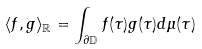Convert formula to latex. <formula><loc_0><loc_0><loc_500><loc_500>\langle f , g \rangle _ { \mathbb { R } } = \int _ { \partial \mathbb { D } } f ( \tau ) g ( \tau ) d \mu ( \tau )</formula> 